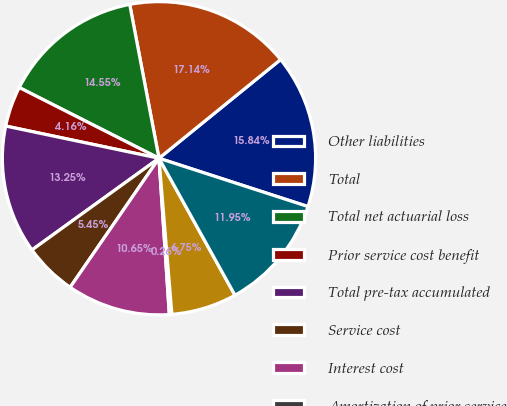<chart> <loc_0><loc_0><loc_500><loc_500><pie_chart><fcel>Other liabilities<fcel>Total<fcel>Total net actuarial loss<fcel>Prior service cost benefit<fcel>Total pre-tax accumulated<fcel>Service cost<fcel>Interest cost<fcel>Amortization of prior service<fcel>Recognized net actuarial loss<fcel>Net periodic benefit cost<nl><fcel>15.84%<fcel>17.14%<fcel>14.55%<fcel>4.16%<fcel>13.25%<fcel>5.45%<fcel>10.65%<fcel>0.26%<fcel>6.75%<fcel>11.95%<nl></chart> 